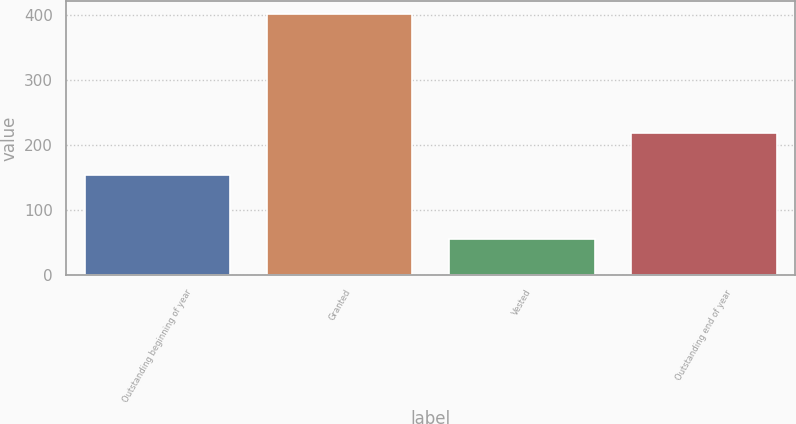<chart> <loc_0><loc_0><loc_500><loc_500><bar_chart><fcel>Outstanding beginning of year<fcel>Granted<fcel>Vested<fcel>Outstanding end of year<nl><fcel>153.4<fcel>401.56<fcel>55.92<fcel>218.34<nl></chart> 